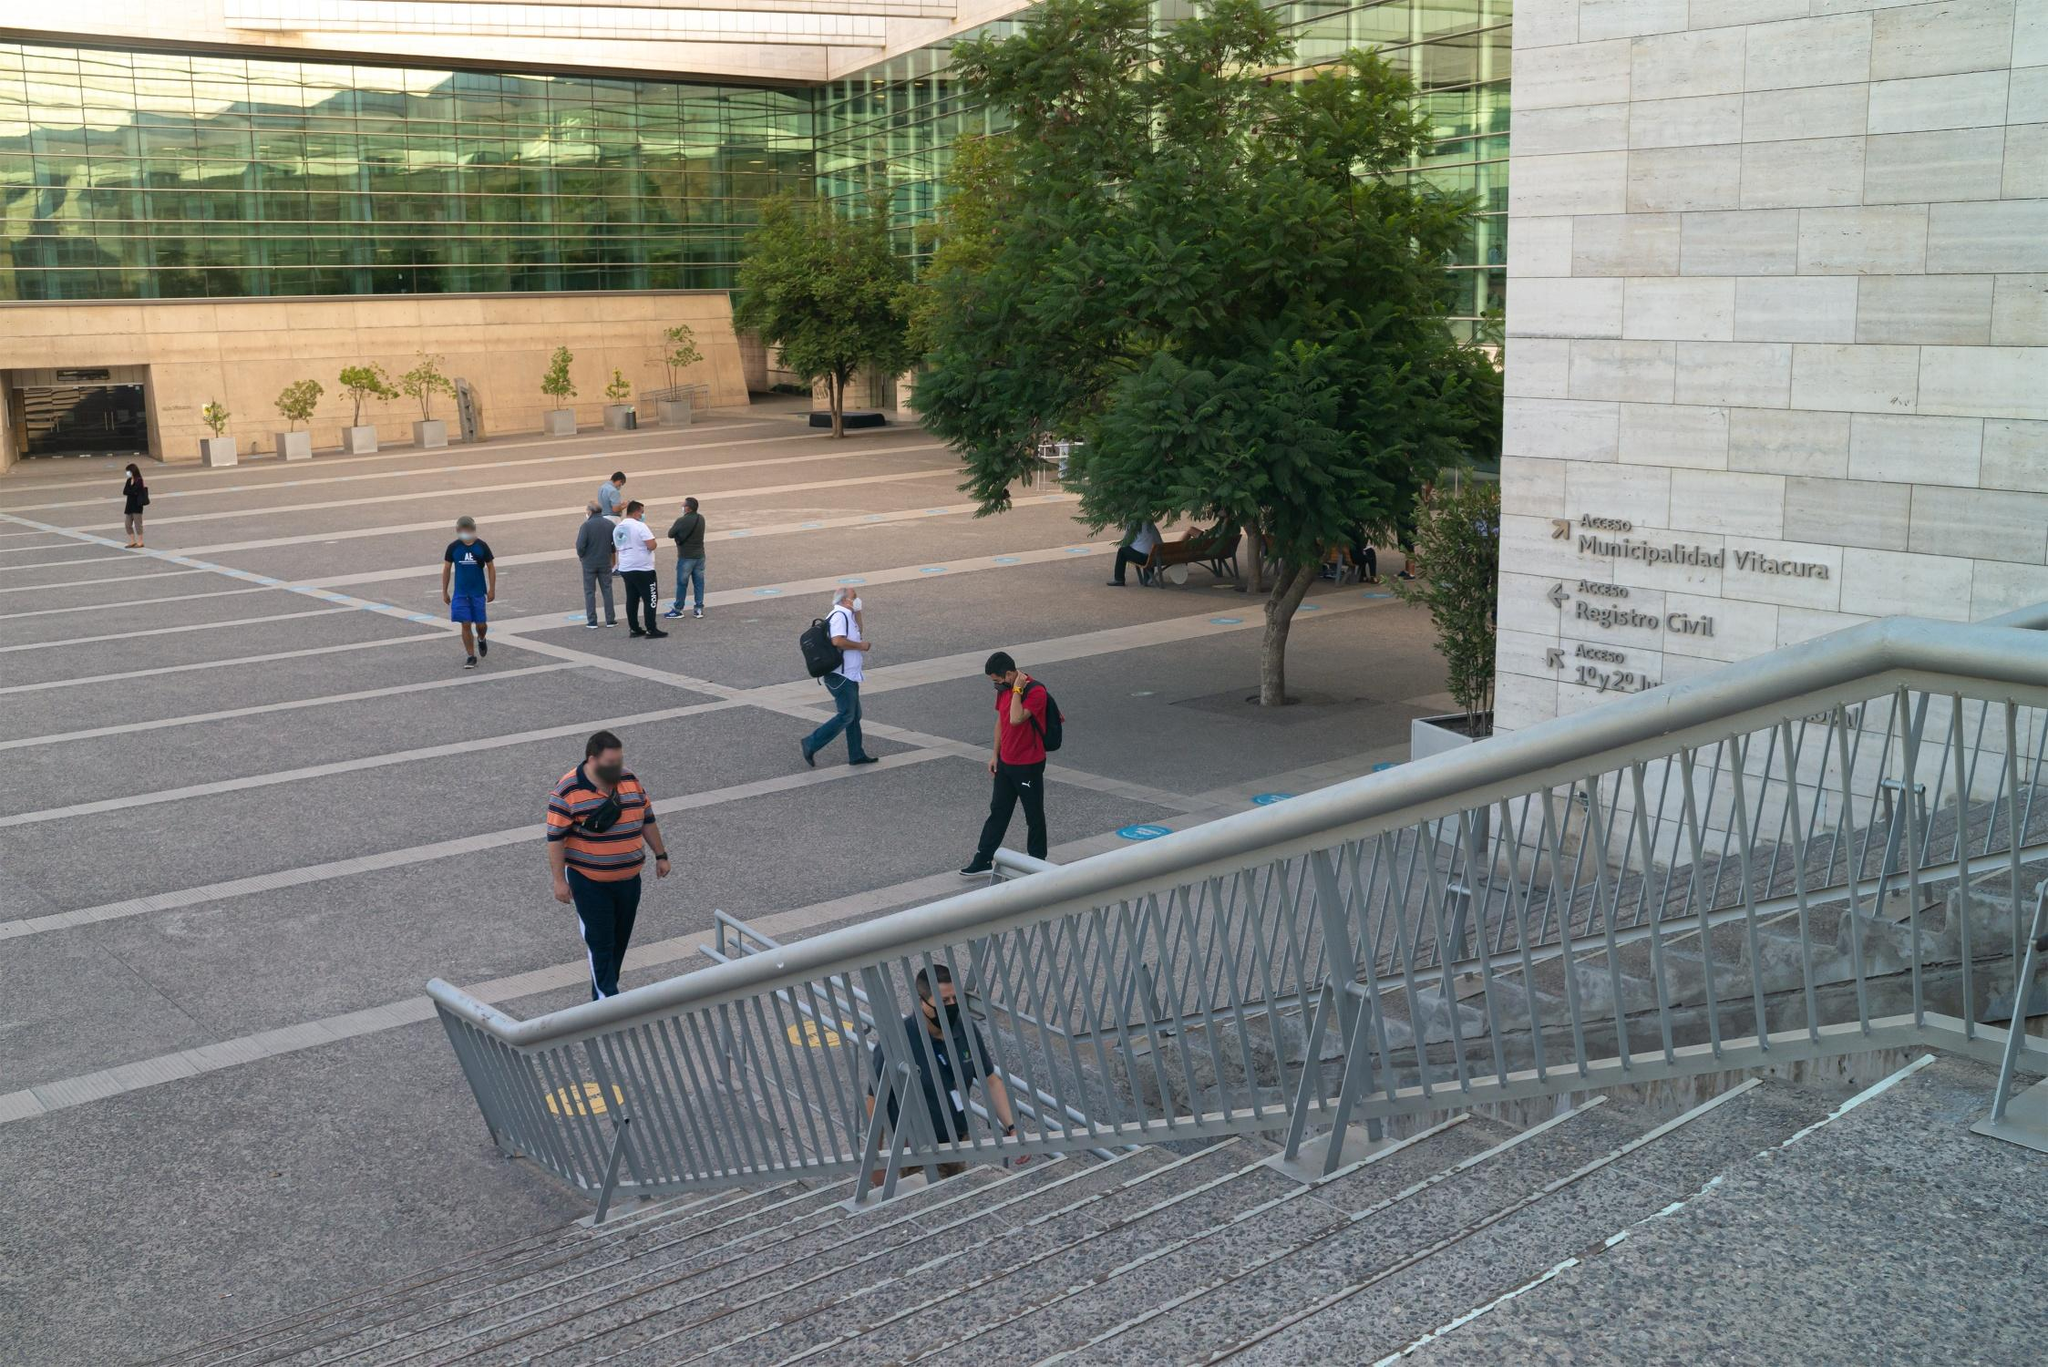What do you see happening in this image? This image features the exterior of a modern building with signage that reads 'Municipalidad de Vitacura', indicating it's a municipal building in Vitacura, a district of Santiago, Chile. The photograph, taken from an elevated angle, shows people engaging in various activities in the spacious courtyard. The area is paved with neat, geometric patterns of tiles and includes a large, leafy tree providing shade. Individuals appear to be casually walking or pausing to chat, contributing to the everyday urban scene. Small, newly planted trees in square, stone planters add to the urban design and greenery of the space. A metal railing in the foreground provides safety and a boundary between different levels of the courtyard. 